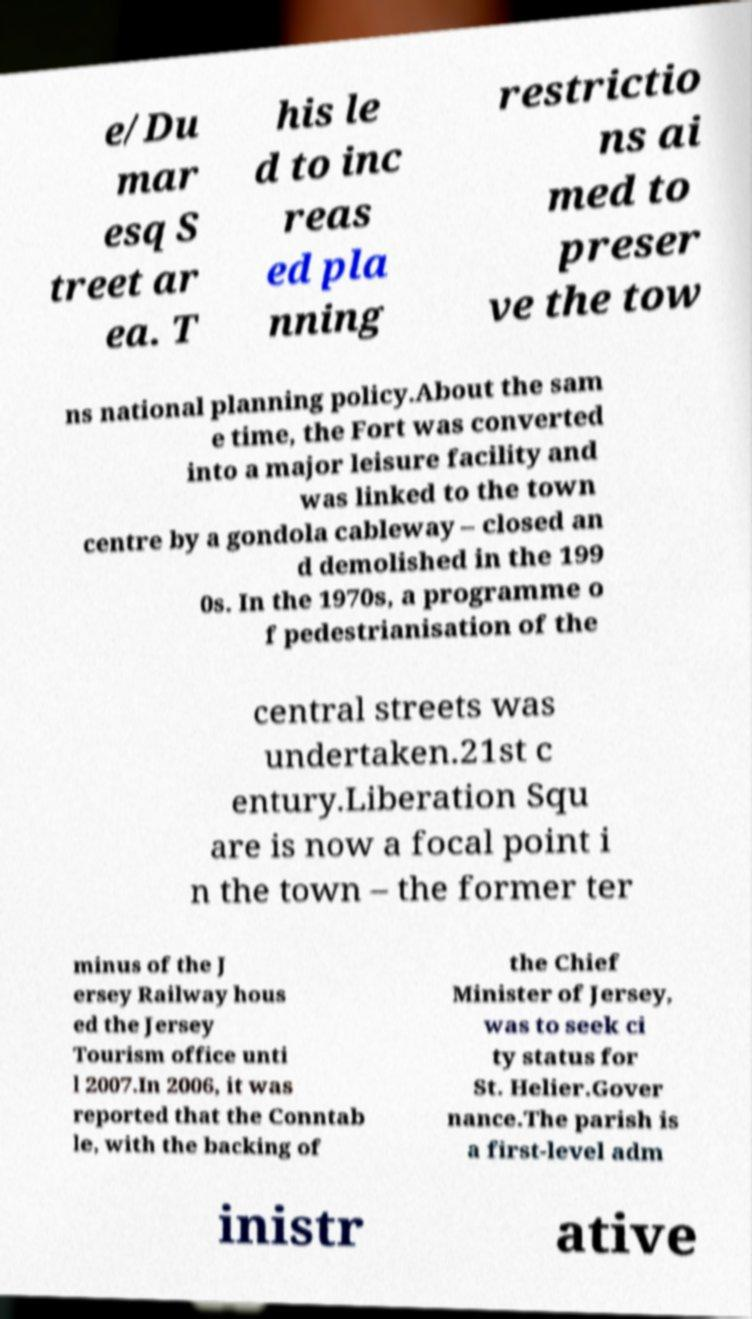What messages or text are displayed in this image? I need them in a readable, typed format. e/Du mar esq S treet ar ea. T his le d to inc reas ed pla nning restrictio ns ai med to preser ve the tow ns national planning policy.About the sam e time, the Fort was converted into a major leisure facility and was linked to the town centre by a gondola cableway – closed an d demolished in the 199 0s. In the 1970s, a programme o f pedestrianisation of the central streets was undertaken.21st c entury.Liberation Squ are is now a focal point i n the town – the former ter minus of the J ersey Railway hous ed the Jersey Tourism office unti l 2007.In 2006, it was reported that the Conntab le, with the backing of the Chief Minister of Jersey, was to seek ci ty status for St. Helier.Gover nance.The parish is a first-level adm inistr ative 